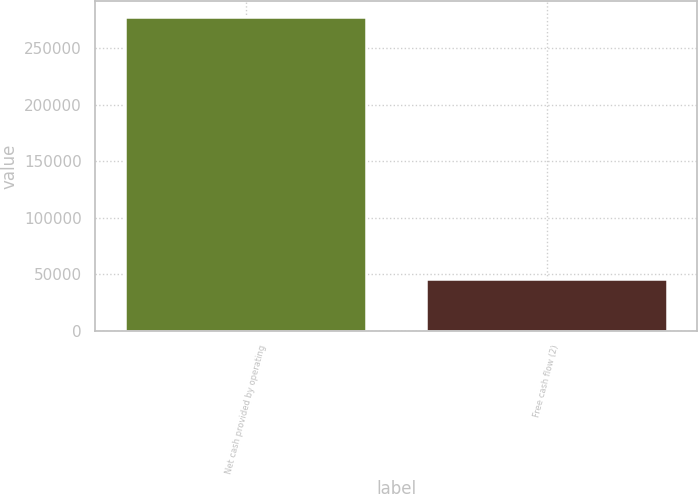Convert chart. <chart><loc_0><loc_0><loc_500><loc_500><bar_chart><fcel>Net cash provided by operating<fcel>Free cash flow (2)<nl><fcel>277420<fcel>45889<nl></chart> 